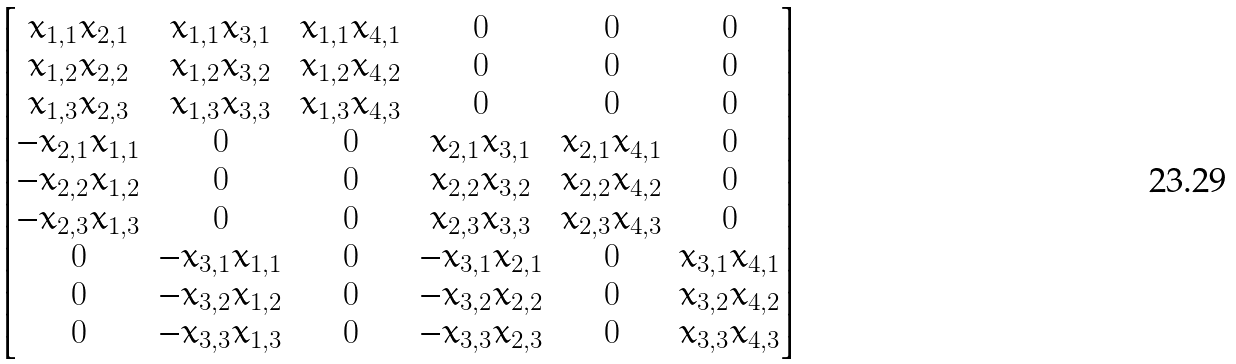<formula> <loc_0><loc_0><loc_500><loc_500>\begin{bmatrix} x _ { 1 , 1 } x _ { 2 , 1 } & x _ { 1 , 1 } x _ { 3 , 1 } & x _ { 1 , 1 } x _ { 4 , 1 } & 0 & 0 & 0 \\ x _ { 1 , 2 } x _ { 2 , 2 } & x _ { 1 , 2 } x _ { 3 , 2 } & x _ { 1 , 2 } x _ { 4 , 2 } & 0 & 0 & 0 \\ x _ { 1 , 3 } x _ { 2 , 3 } & x _ { 1 , 3 } x _ { 3 , 3 } & x _ { 1 , 3 } x _ { 4 , 3 } & 0 & 0 & 0 \\ - x _ { 2 , 1 } x _ { 1 , 1 } & 0 & 0 & x _ { 2 , 1 } x _ { 3 , 1 } & x _ { 2 , 1 } x _ { 4 , 1 } & 0 \\ - x _ { 2 , 2 } x _ { 1 , 2 } & 0 & 0 & x _ { 2 , 2 } x _ { 3 , 2 } & x _ { 2 , 2 } x _ { 4 , 2 } & 0 \\ - x _ { 2 , 3 } x _ { 1 , 3 } & 0 & 0 & x _ { 2 , 3 } x _ { 3 , 3 } & x _ { 2 , 3 } x _ { 4 , 3 } & 0 \\ 0 & - x _ { 3 , 1 } x _ { 1 , 1 } & 0 & - x _ { 3 , 1 } x _ { 2 , 1 } & 0 & x _ { 3 , 1 } x _ { 4 , 1 } \\ 0 & - x _ { 3 , 2 } x _ { 1 , 2 } & 0 & - x _ { 3 , 2 } x _ { 2 , 2 } & 0 & x _ { 3 , 2 } x _ { 4 , 2 } \\ 0 & - x _ { 3 , 3 } x _ { 1 , 3 } & 0 & - x _ { 3 , 3 } x _ { 2 , 3 } & 0 & x _ { 3 , 3 } x _ { 4 , 3 } \\ \end{bmatrix}</formula> 